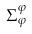Convert formula to latex. <formula><loc_0><loc_0><loc_500><loc_500>\Sigma _ { \varphi } ^ { \varphi }</formula> 